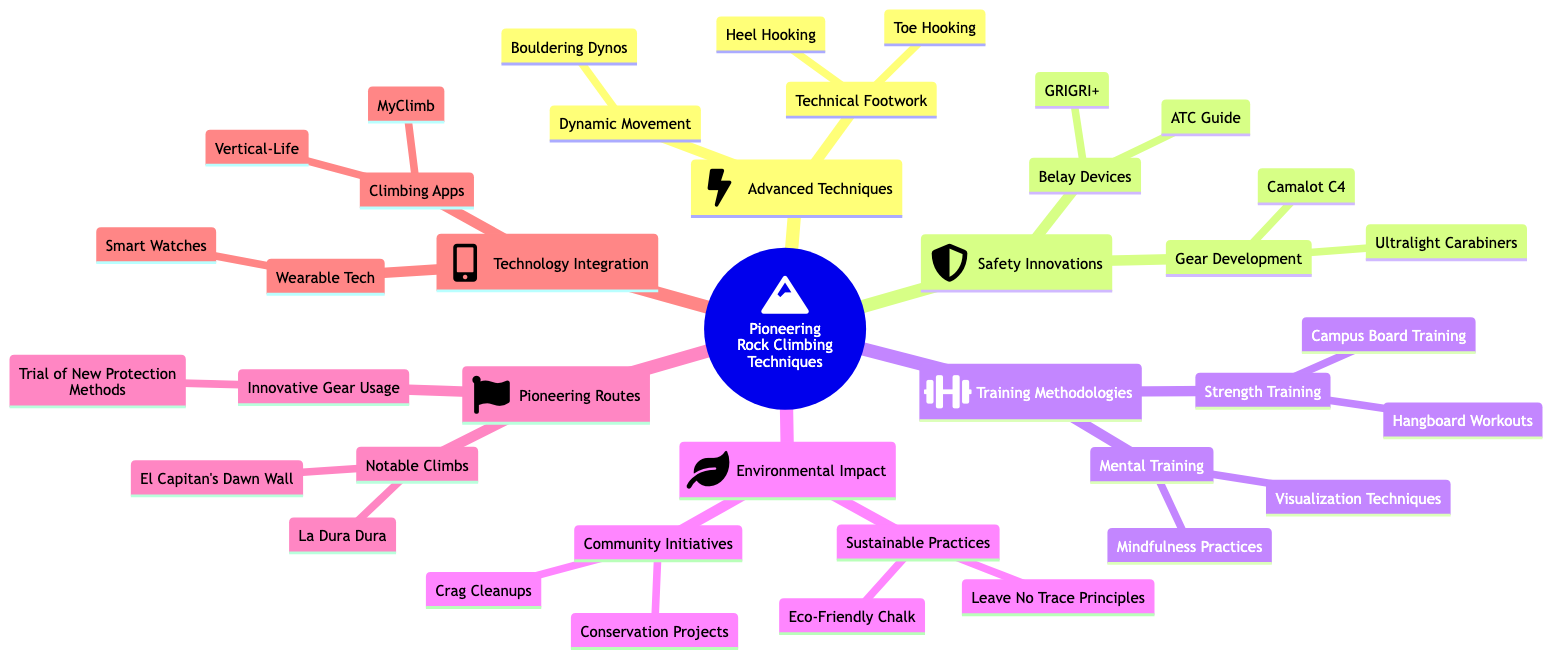What are the two techniques listed under Advanced Climbing Techniques? The diagram shows two techniques categorized under Advanced Climbing Techniques: Dynamic Movement and Technical Footwork. Each of these has specific techniques associated with them. Thus, the answer is the names of these two techniques, which are accessible in the first layer of that category.
Answer: Dynamic Movement, Technical Footwork How many types of Safety Innovations are mentioned? Safety Innovations is a main category in the diagram. It contains two sub-categories: Gear Development and Belay Devices. Therefore, the total number of types under Safety Innovations is the count of these sub-categories.
Answer: 2 What notable climbs are included in the Pioneering Routes section? The Pioneering Routes section includes a list of notable climbs. By examining this category, we find two notable climbs: El Capitan's Dawn Wall and La Dura Dura. The answer is derived from the names listed in this part of the mind map.
Answer: El Capitan's Dawn Wall, La Dura Dura Which belay device is categorized under Safety Innovations? Within the Safety Innovations category, there are sub-categories including Gear Development and Belay Devices. Under Belay Devices, specific devices, including GRIGRI+ and ATC Guide, are listed. Therefore, the answer reflects the mention of these specific devices.
Answer: GRIGRI+, ATC Guide Which category encompasses Training Methodologies? Looking at the structure of the diagram, we can see that Training Methodologies is a main category. It consists of two sub-categories: Strength Training and Mental Training. Therefore, the correct answer identifies this main category reflecting the focus on training.
Answer: Training Methodologies What are two examples of mental training practices mentioned? In the Training Methodologies section, specifically under Mental Training, there are two mentioned practices: Visualization Techniques and Mindfulness Practices. The answer derives directly from these specific items listed under Mental Training.
Answer: Visualization Techniques, Mindfulness Practices How many climbing apps are identified in the Technology Integration segment? The Technology Integration section lists Climbing Apps as one of the categories. Under this category, two specific climbing app names are mentioned: MyClimb and Vertical-Life. Thus, the answer is obtained from counting these specific items in the diagram.
Answer: 2 What sustainable practice is mentioned under Environmental Impact? The Environmental Impact category highlights Sustainable Practices, where Leave No Trace Principles and Eco-Friendly Chalk are mentioned. Therefore, the answer identifies any one of these practices given the context requested.
Answer: Leave No Trace Principles 